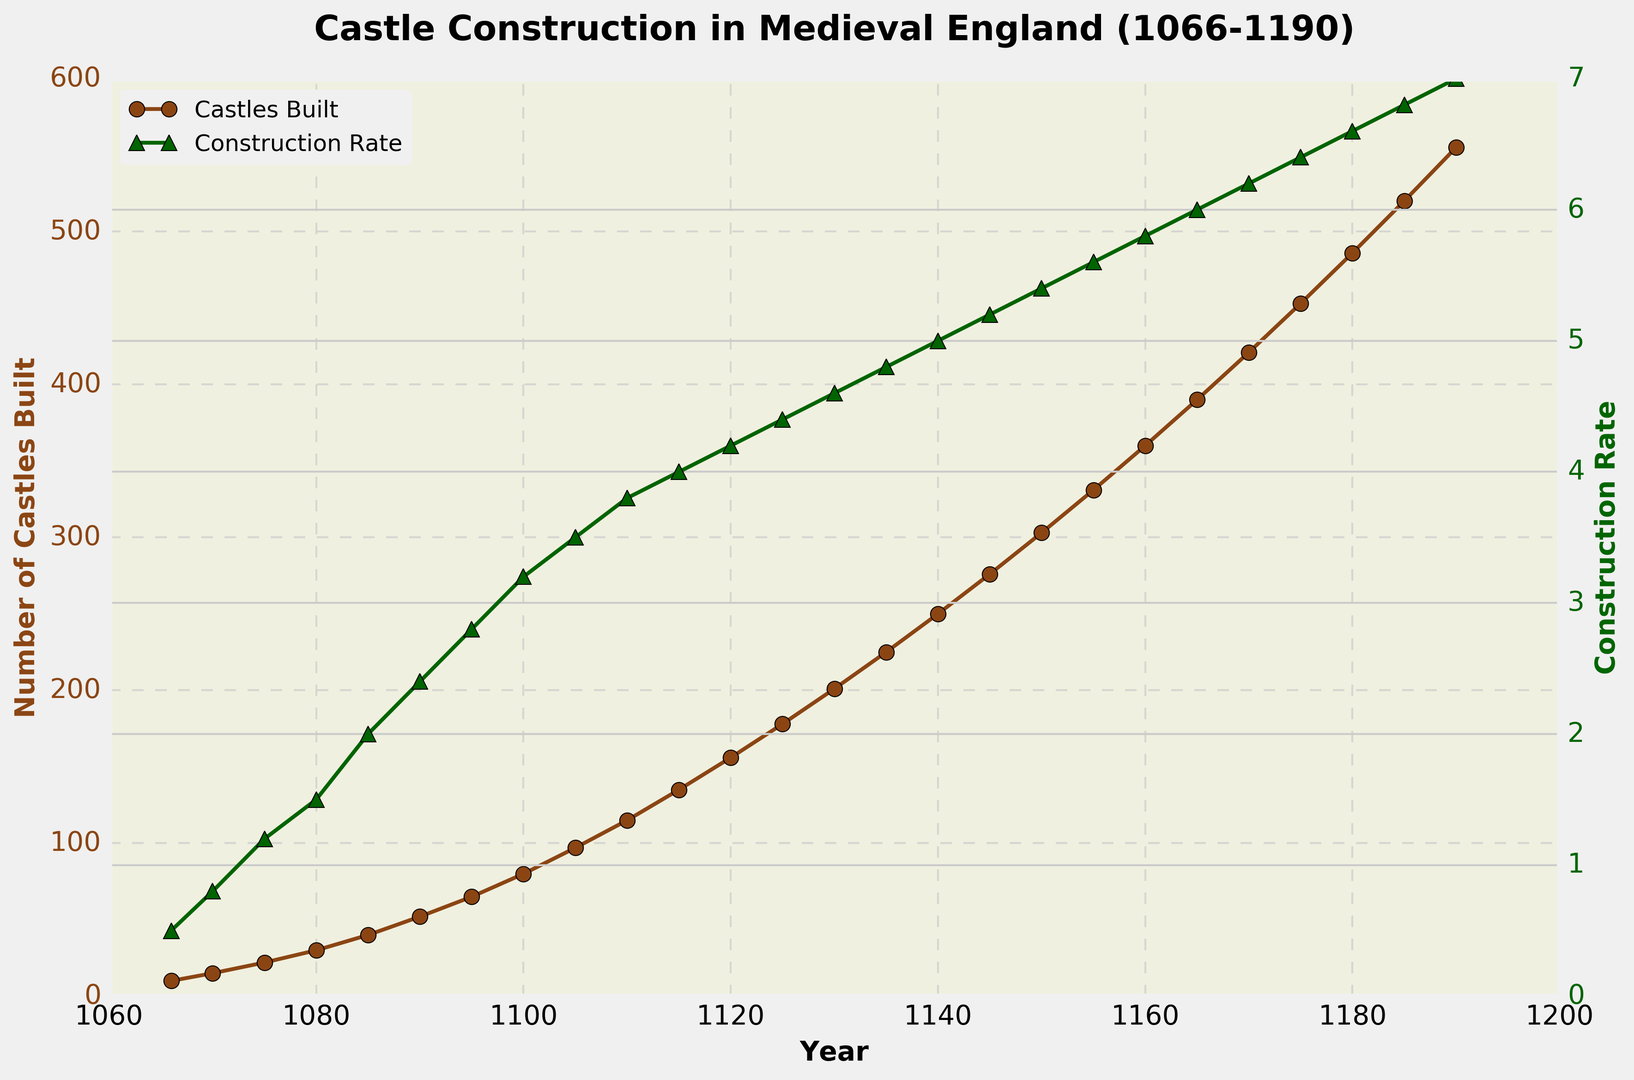When did the construction rate first reach 4.0 castles per year, and how many castles had been built by then? The construction rate reached 4.0 castles per year in 1115, according to the green line on the right vertical axis. By that year, the graph shows that 135 castles had been built, as indicated by the brown line on the left vertical axis.
Answer: 1115, 135 Which year shows the largest increase in the number of castles built compared to the previous data point? Looking at the brown line, the largest single-year increase in the number of castles built is from 1190 to 1185 (486 to 520 castles), which is an increase of 34 castles.
Answer: 1185 to 1190 How does the visual representation of the construction rate change over the timeline? The green line representing the construction rate generally increases steadily over time, with no significant downward dips, indicating a continuous growth in the rate at which castles were built.
Answer: Steady increase What was the average construction rate from 1066 to 1075? Summing the construction rates from 1066 to 1075 (0.5 + 0.8 + 1.2) and dividing by 3 gives the average construction rate. (0.5 + 0.8 + 1.2) / 3 = 2.5 / 3 = 0.83̅.
Answer: 0.83̅ Compare the construction rate in 1100 to that in 1075. How much did it increase by? The construction rate in 1075 was 1.2 castles per year, and in 1100, it was 3.2 castles per year. To find the increase, subtract the earlier rate from the later rate: 3.2 - 1.2 = 2.0.
Answer: 2.0 In which year did the number of castles built reach 200, and what was the construction rate that year? The graph shows that 200 castles were built by 1130. In that year, the construction rate was 4.6 castles per year, as indicated by the green line.
Answer: 1130, 4.6 How many castles were built from 1085 to 1095? Subtract the number of castles built by 1085 from the number by 1095 to get the total for this period: 65 - 40 = 25.
Answer: 25 What visual cues help identify changes in construction rates? The green line's ascent rate, marked by triangles, accompanies each year along with the vertical grid lines for easy reference. Increasing line steepness indicates rising construction rates.
Answer: Line steepness and markers How much did the construction rate increase from 1150 to 1160? The construction rate in 1150 was 5.4 castles per year, and in 1160 it was 5.8 castles per year. The difference is 5.8 - 5.4 = 0.4.
Answer: 0.4 What trend can you observe in the number of castles built between 1066 and 1190? The number of castles built steadily increases over time, with no significant period of decline, indicating a continuous, possibly accelerating, effort in castle construction.
Answer: Continuous increase 